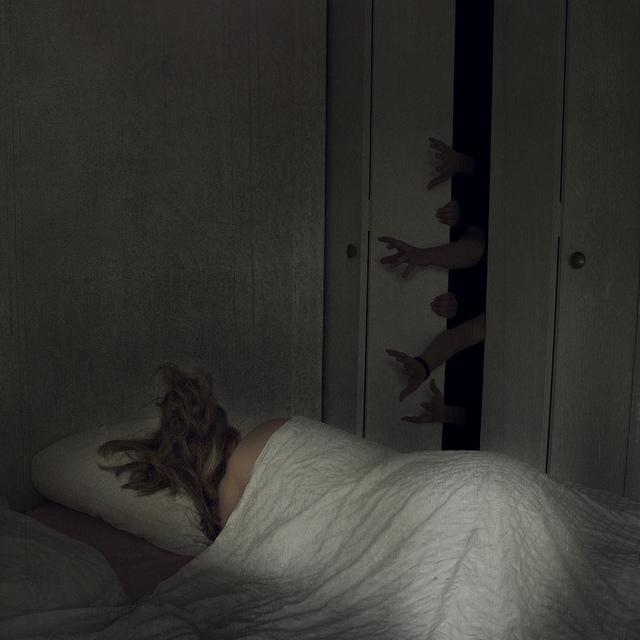What are coming out of the closet?

Choices:
A) hands
B) heads
C) tentacles
D) feet hands 